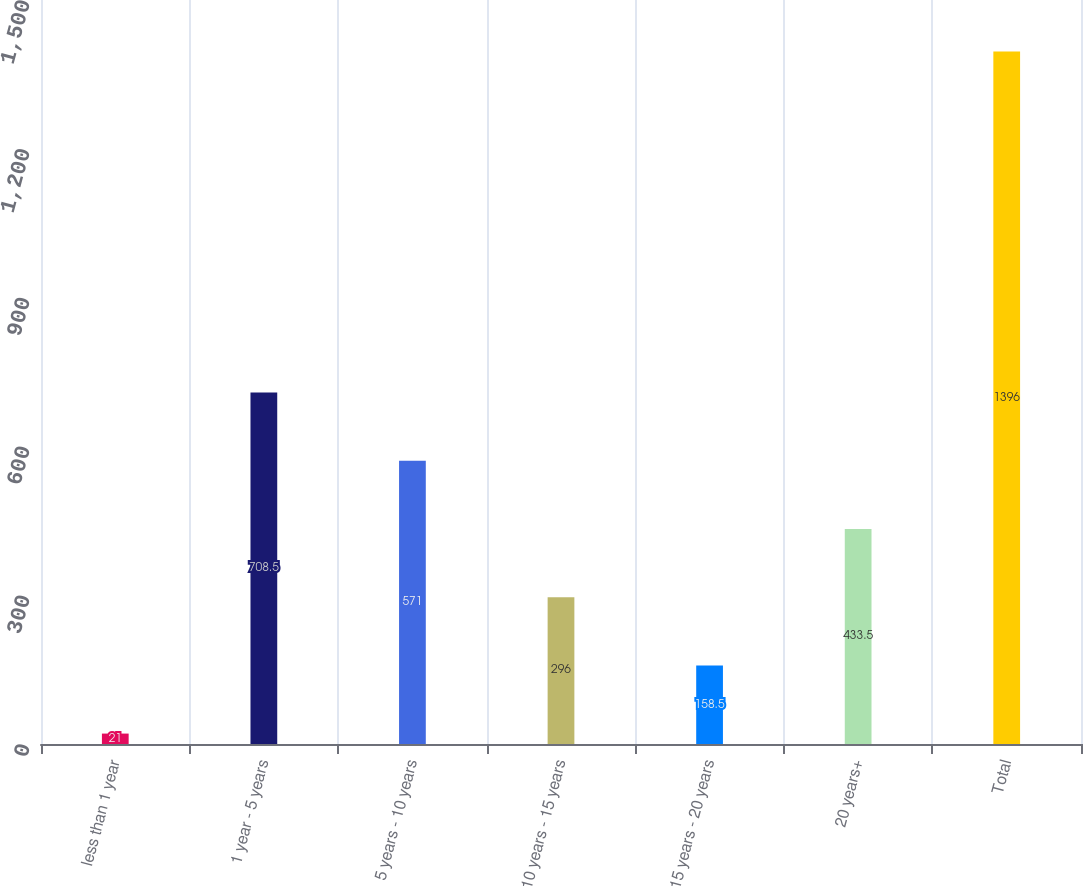Convert chart. <chart><loc_0><loc_0><loc_500><loc_500><bar_chart><fcel>less than 1 year<fcel>1 year - 5 years<fcel>5 years - 10 years<fcel>10 years - 15 years<fcel>15 years - 20 years<fcel>20 years+<fcel>Total<nl><fcel>21<fcel>708.5<fcel>571<fcel>296<fcel>158.5<fcel>433.5<fcel>1396<nl></chart> 